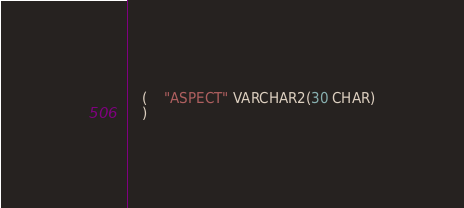<code> <loc_0><loc_0><loc_500><loc_500><_SQL_>   (	"ASPECT" VARCHAR2(30 CHAR)
   ) </code> 